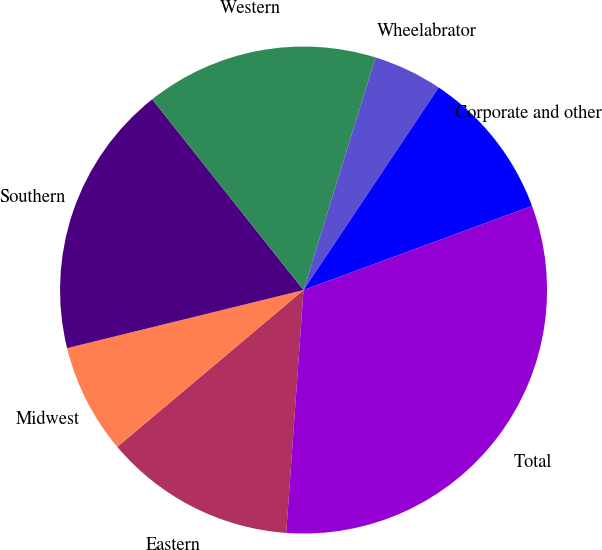Convert chart to OTSL. <chart><loc_0><loc_0><loc_500><loc_500><pie_chart><fcel>Eastern<fcel>Midwest<fcel>Southern<fcel>Western<fcel>Wheelabrator<fcel>Corporate and other<fcel>Total<nl><fcel>12.73%<fcel>7.3%<fcel>18.16%<fcel>15.45%<fcel>4.59%<fcel>10.02%<fcel>31.74%<nl></chart> 